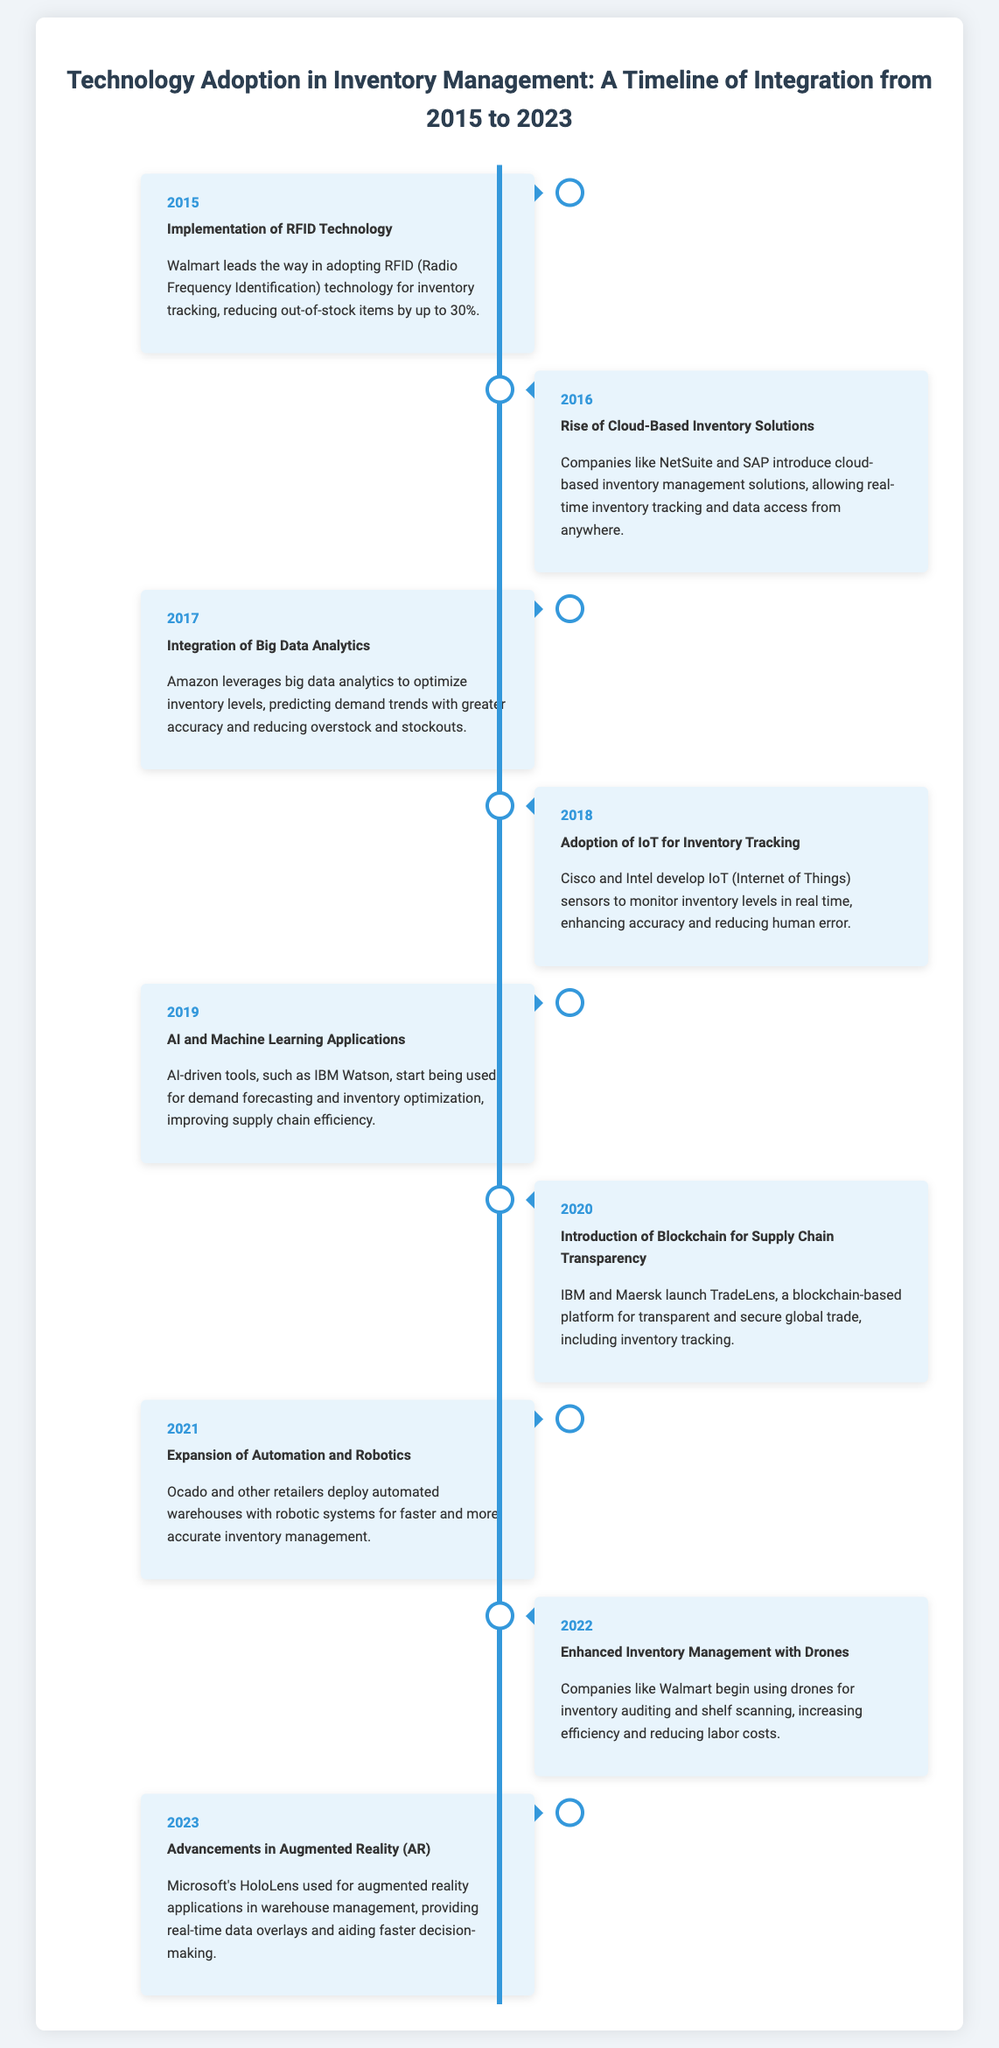What technology was implemented in 2015? The event in 2015 was the implementation of RFID technology for inventory tracking.
Answer: RFID Technology What year did the rise of cloud-based inventory solutions occur? The event regarding cloud-based inventory solutions occurred in 2016.
Answer: 2016 Which company developed IoT sensors in 2018? Cisco and Intel developed IoT sensors to monitor inventory levels in 2018.
Answer: Cisco and Intel What was introduced in the year 2020? In 2020, blockchain for supply chain transparency was introduced.
Answer: Blockchain How did companies use drones in 2022? In 2022, companies began using drones for inventory auditing and shelf scanning.
Answer: Inventory auditing and shelf scanning What advancement was made in 2023? The advancement made in 2023 was the use of augmented reality (AR) in warehouse management.
Answer: Augmented Reality Which company is associated with AI and machine learning applications in inventory management? IBM Watson is associated with AI and machine learning applications for demand forecasting.
Answer: IBM Watson What percentage of out-of-stock items did Walmart reduce with RFID technology? RFID technology helped reduce out-of-stock items by up to 30%.
Answer: 30% What type of platform did IBM and Maersk launch? They launched a blockchain-based platform for transparent and secure global trade.
Answer: Blockchain-based platform 